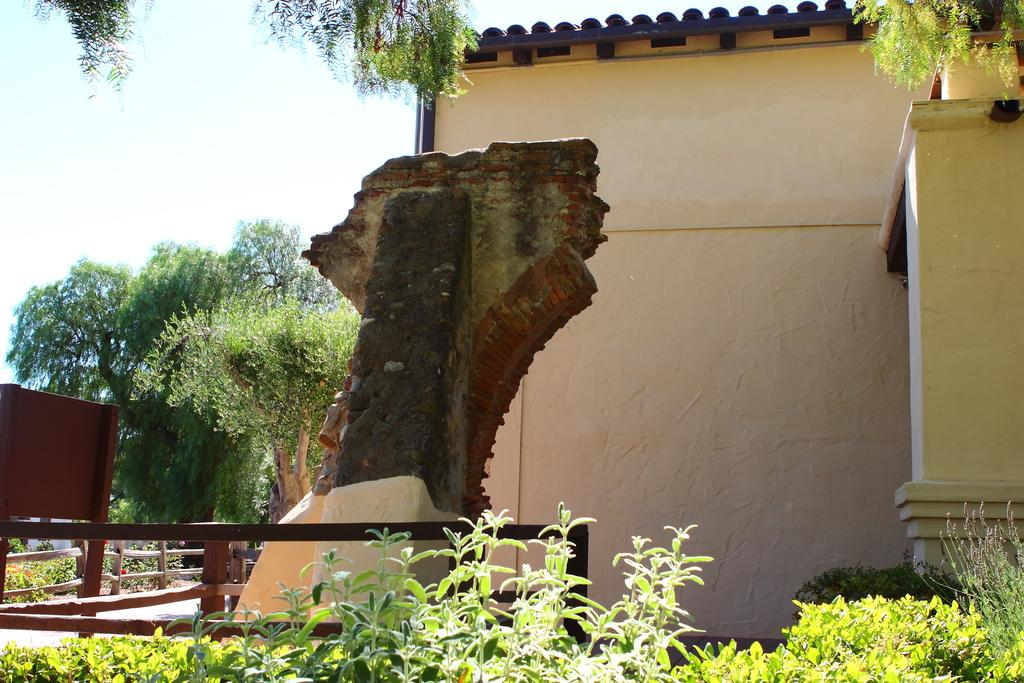What type of structure is present in the image? There is a house in the image. What other natural elements can be seen in the image? There are plants, trees, and the sky visible in the image. Is there any barrier or enclosure in the image? Yes, there is a fence in the image. How does the beggar interact with the house in the image? There is no beggar present in the image, so it is not possible to answer that question. 